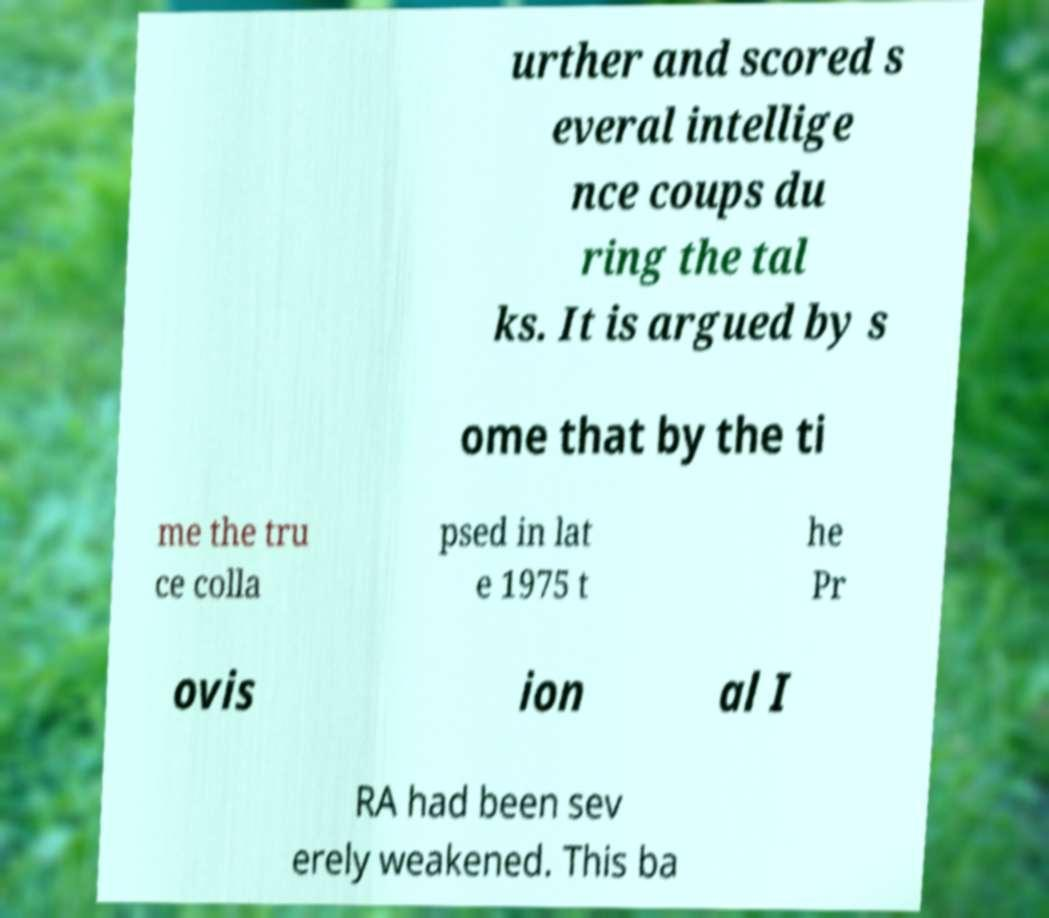Could you assist in decoding the text presented in this image and type it out clearly? urther and scored s everal intellige nce coups du ring the tal ks. It is argued by s ome that by the ti me the tru ce colla psed in lat e 1975 t he Pr ovis ion al I RA had been sev erely weakened. This ba 